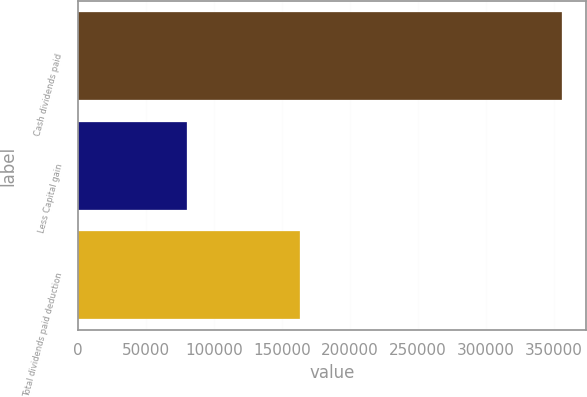<chart> <loc_0><loc_0><loc_500><loc_500><bar_chart><fcel>Cash dividends paid<fcel>Less Capital gain<fcel>Total dividends paid deduction<nl><fcel>355782<fcel>80069<fcel>163533<nl></chart> 